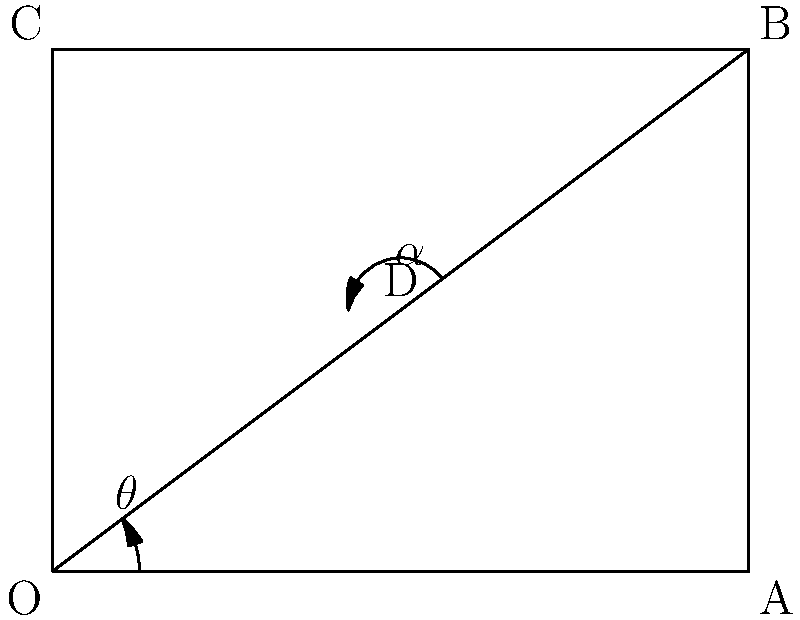In a free-kick situation, a player aims to curve the ball around a defensive wall. The kick is taken from point O, and the goal is located at point B. The ball's trajectory forms an arc that passes through point D. Given that $\overline{OA} = 40$ meters, $\overline{AB} = 30$ meters, and $\angle AOD = 20°$, calculate the angle $\alpha$ at which the ball needs to be struck to reach the goal. Round your answer to the nearest degree. To solve this problem, we'll follow these steps:

1) First, let's identify the known information:
   $\overline{OA} = 40$ m
   $\overline{AB} = 30$ m
   $\angle AOD = 20°$

2) We need to find $\angle OBA$ (let's call it $\theta$):
   $\tan \theta = \frac{\overline{AB}}{\overline{OA}} = \frac{30}{40} = 0.75$
   $\theta = \arctan(0.75) \approx 36.87°$

3) Now we can find $\angle AOB$:
   $\angle AOB = 90° - \theta \approx 53.13°$

4) The angle $\alpha$ we're looking for is the supplementary angle to $\angle DOB$:
   $\alpha = 180° - \angle DOB$

5) We can find $\angle DOB$ by subtracting $\angle AOD$ from $\angle AOB$:
   $\angle DOB = \angle AOB - \angle AOD = 53.13° - 20° = 33.13°$

6) Therefore:
   $\alpha = 180° - 33.13° = 146.87°$

7) Rounding to the nearest degree:
   $\alpha \approx 147°$
Answer: 147° 